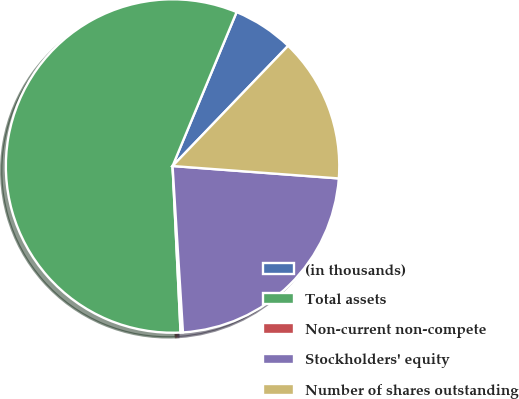Convert chart to OTSL. <chart><loc_0><loc_0><loc_500><loc_500><pie_chart><fcel>(in thousands)<fcel>Total assets<fcel>Non-current non-compete<fcel>Stockholders' equity<fcel>Number of shares outstanding<nl><fcel>5.91%<fcel>57.04%<fcel>0.23%<fcel>22.82%<fcel>14.0%<nl></chart> 